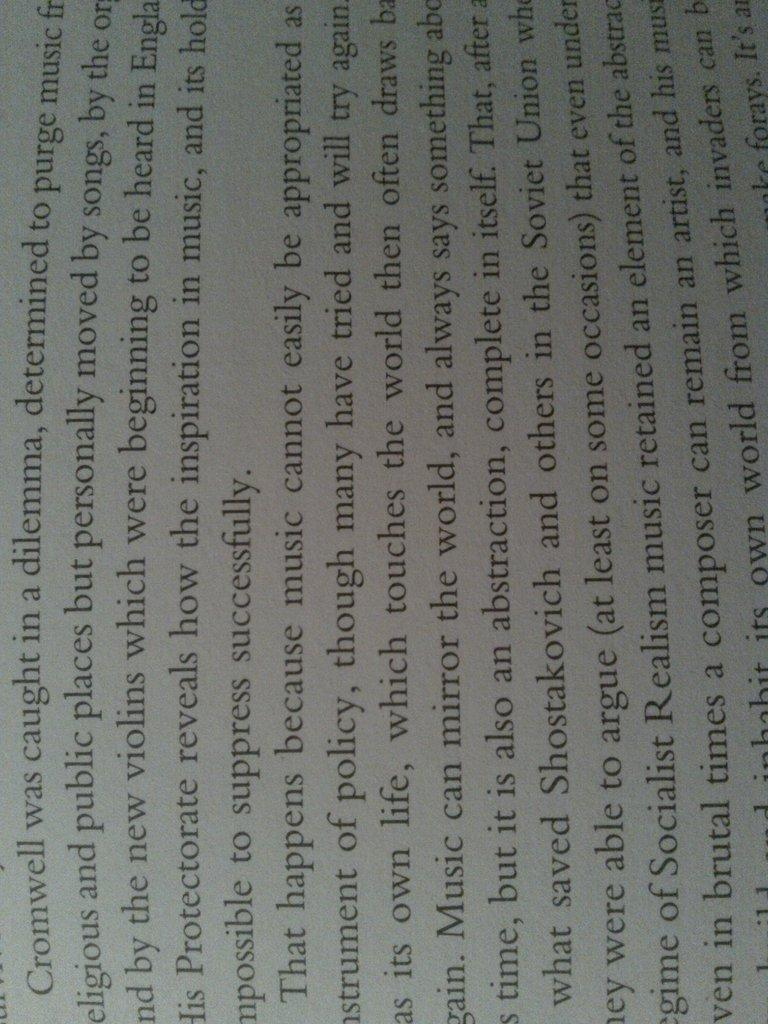<image>
Present a compact description of the photo's key features. A paragraph in this book starts with Cromwell and ends with successfully. 